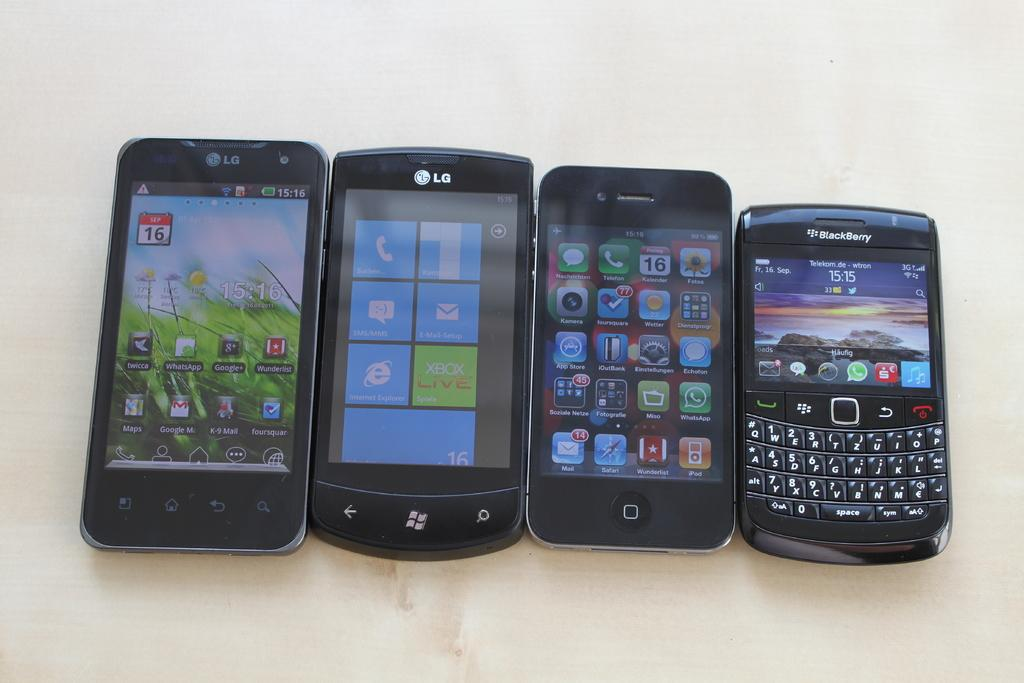<image>
Provide a brief description of the given image. A row of devices lined up from big to small, one of which is a Blackberry. 